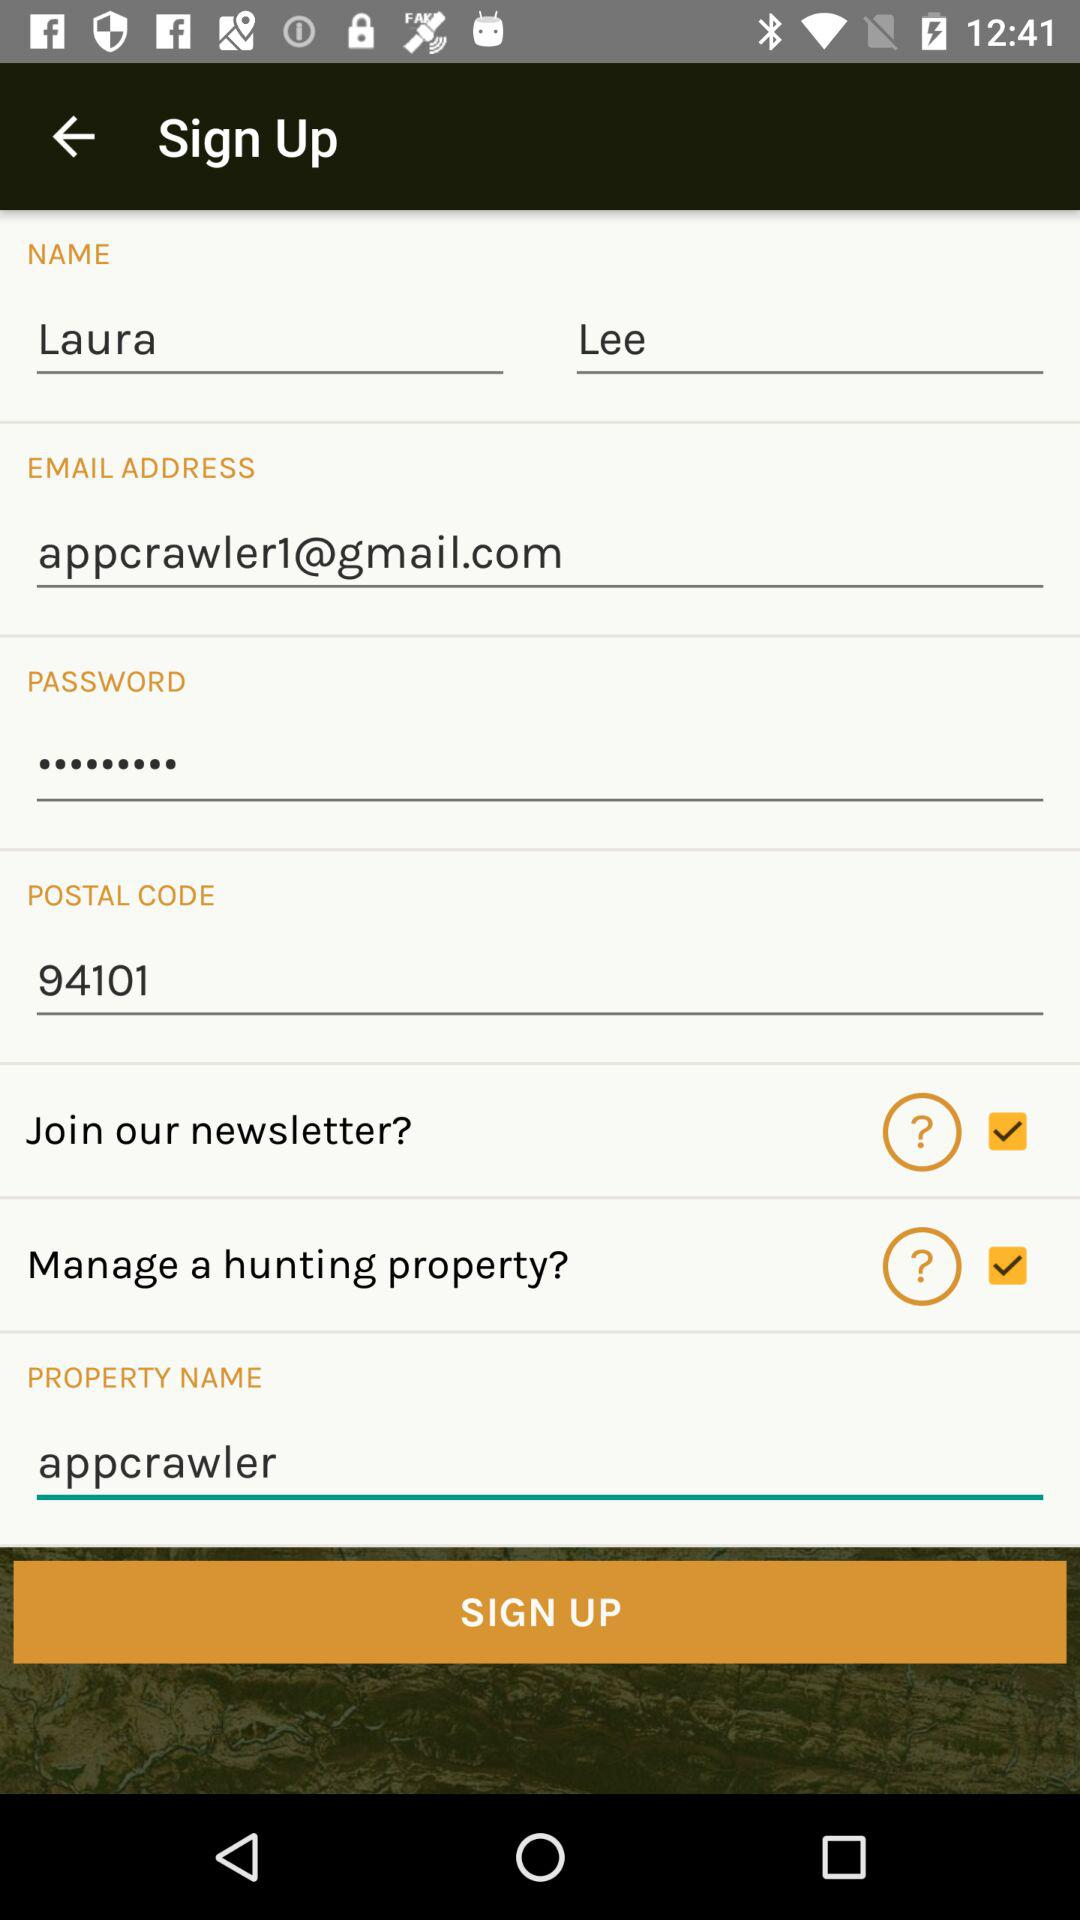What is the first name? The first name is Laura. 